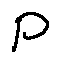Convert formula to latex. <formula><loc_0><loc_0><loc_500><loc_500>P</formula> 